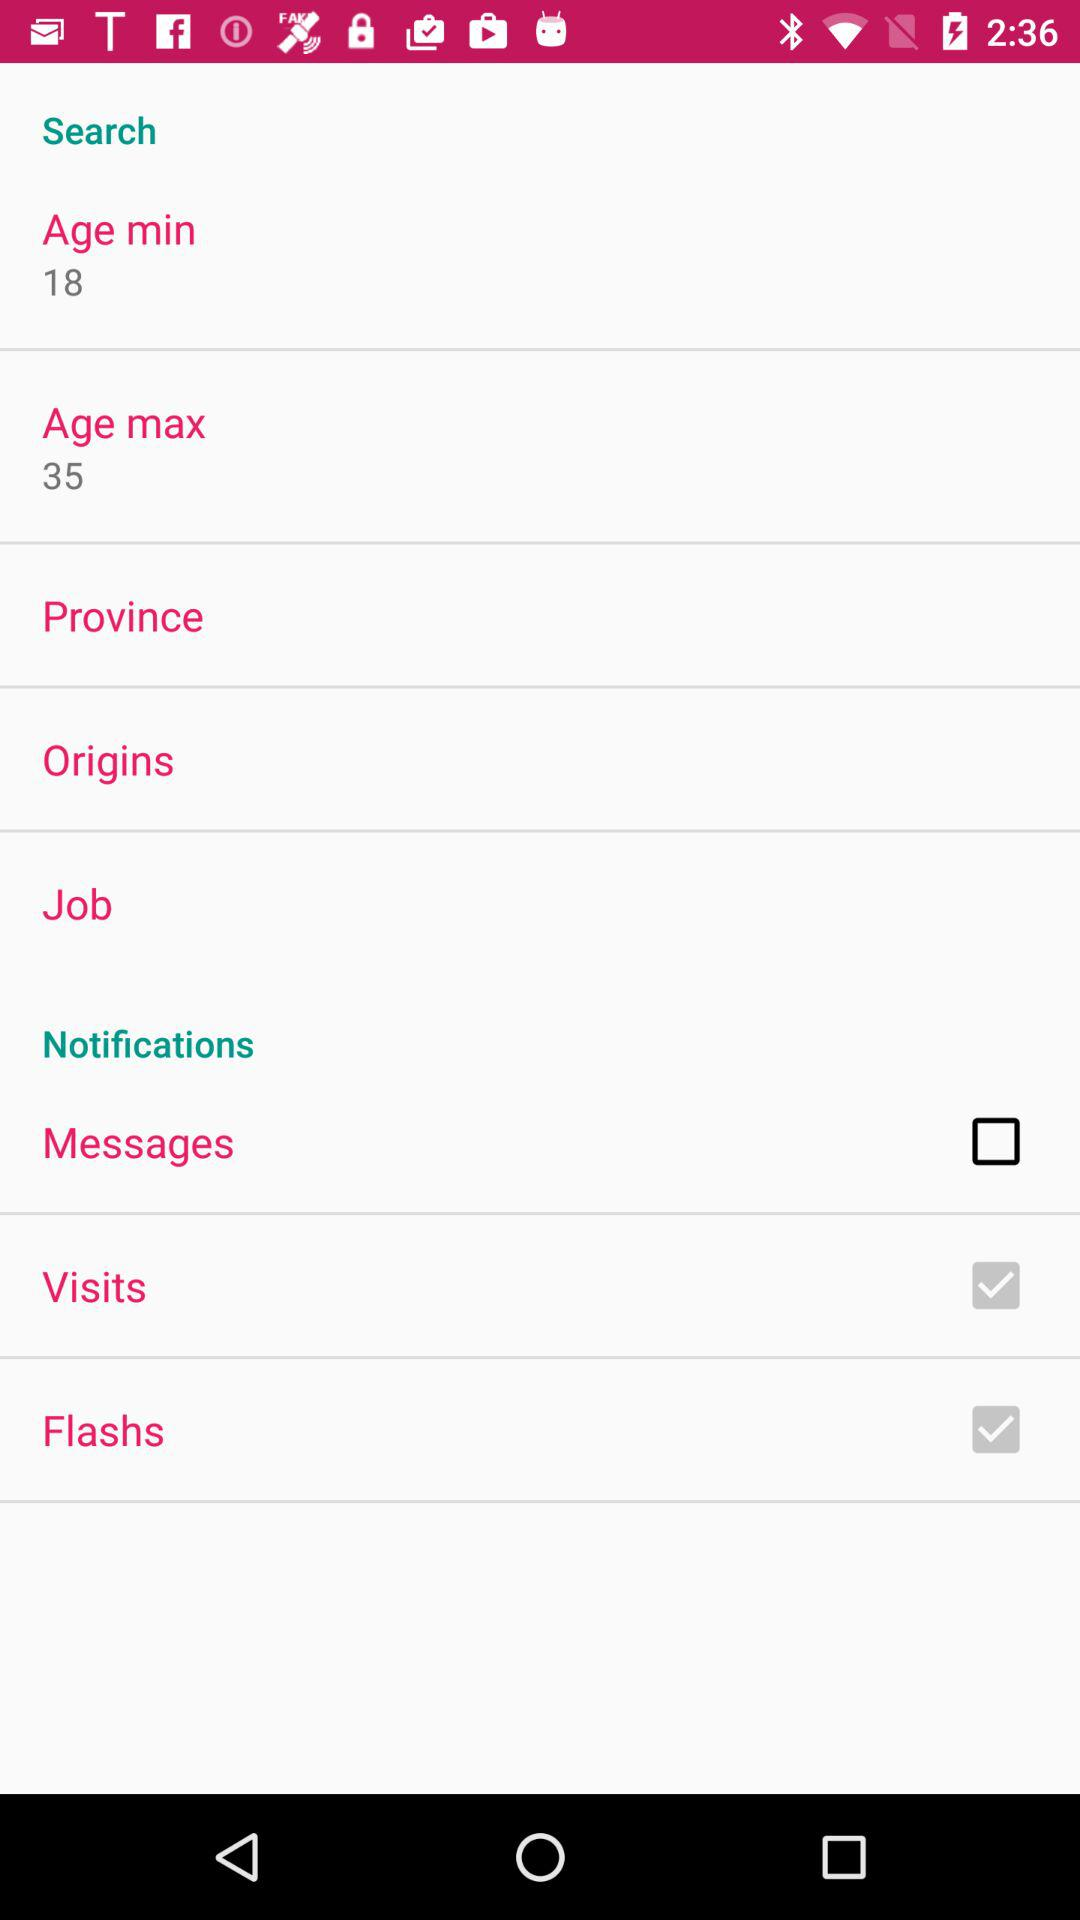What is the maximum age limit? The maximum age limit is 35. 